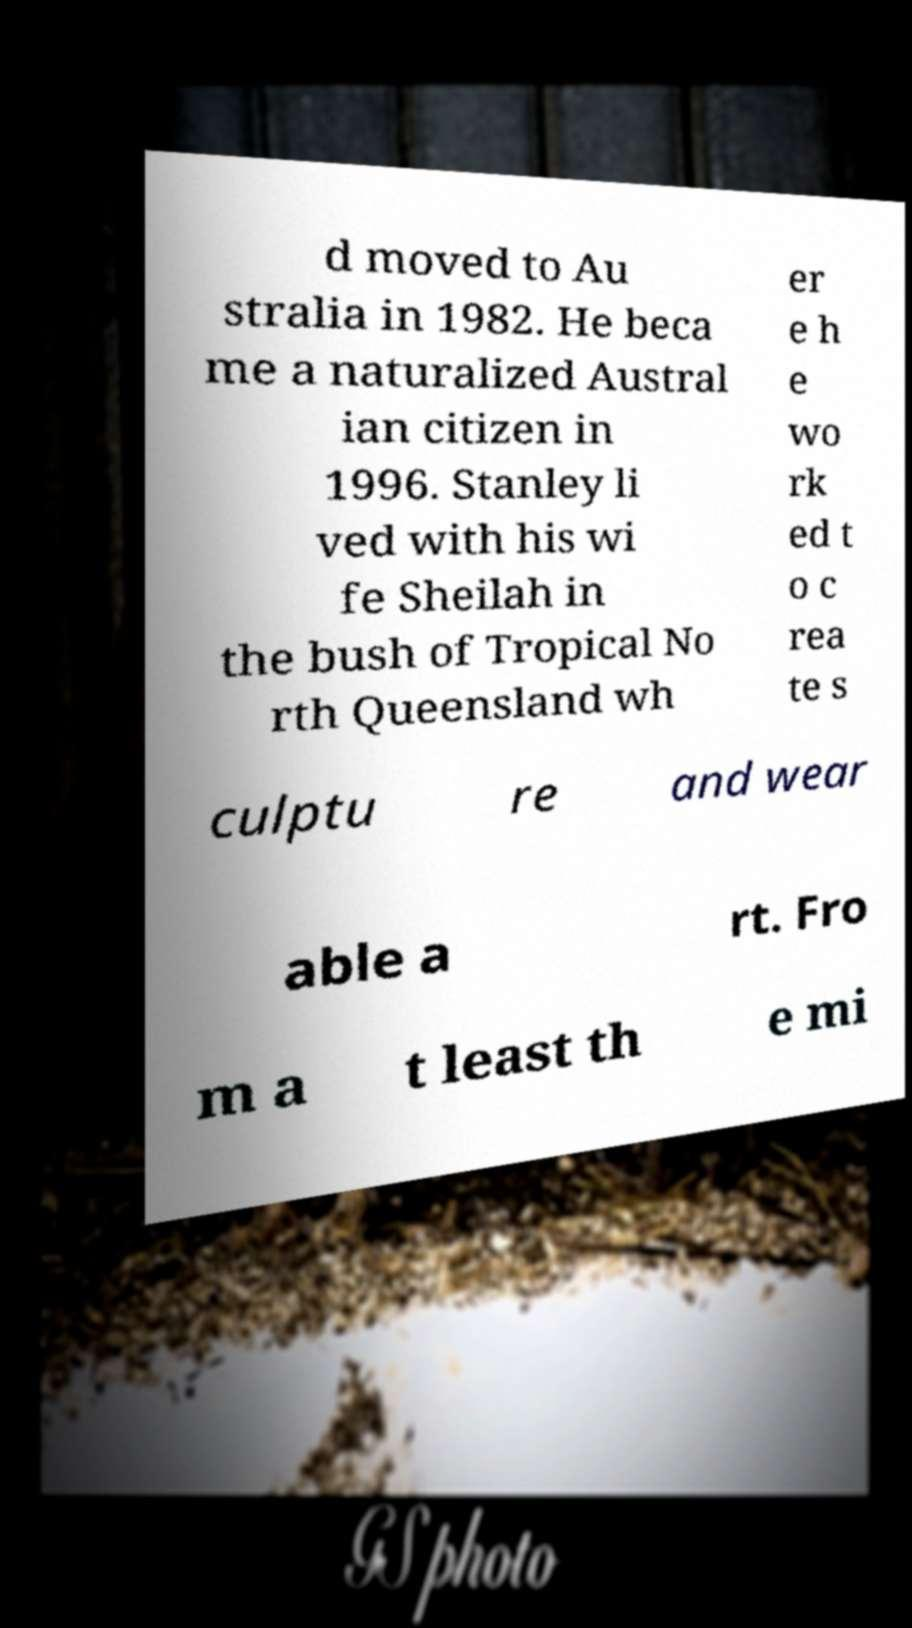Could you extract and type out the text from this image? d moved to Au stralia in 1982. He beca me a naturalized Austral ian citizen in 1996. Stanley li ved with his wi fe Sheilah in the bush of Tropical No rth Queensland wh er e h e wo rk ed t o c rea te s culptu re and wear able a rt. Fro m a t least th e mi 